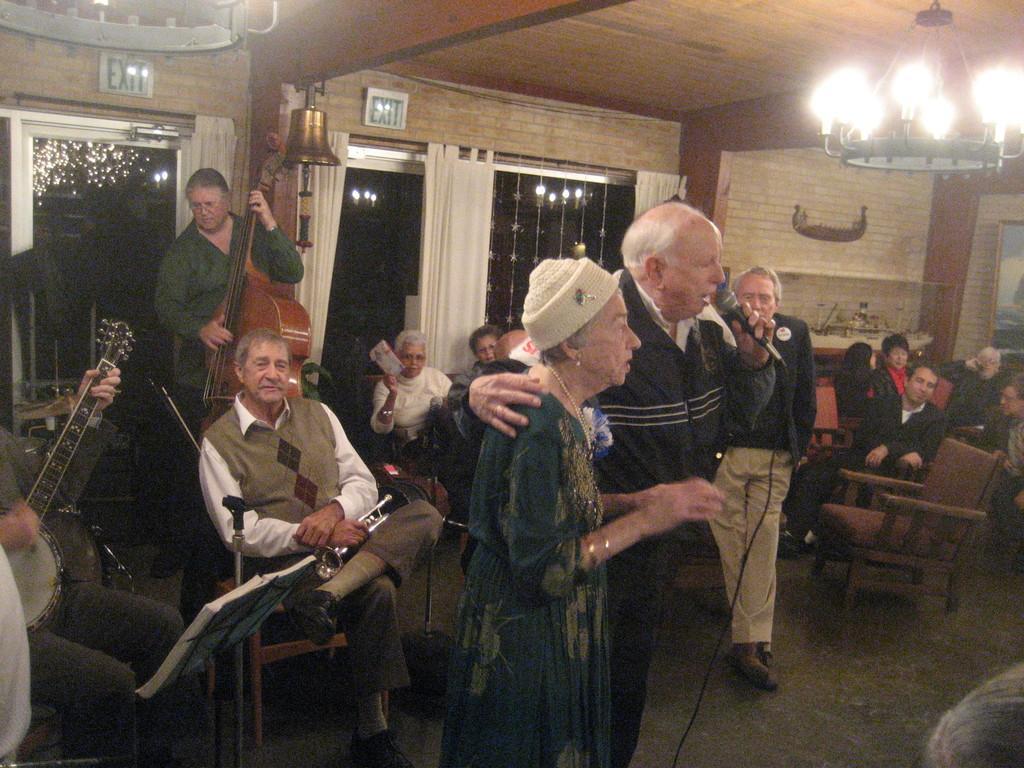Describe this image in one or two sentences. This picture shows the inner view of a room, one light set attached to the ceiling, dome lights, few objects hangs near the glass door, some curtains attached to the glass doors, one object attached to the ceiling, some chairs, one bell hanged to the ceiling, some people are sitting on the chairs, two person´s playing musical instruments, few objects attached to the wall, one frame attached to the wall, some objects on the floor, some objects on the table near the wall, one book on the stand, few people are standing, few people are holding objects, one man holding a microphone and singing in the middle of the image. 